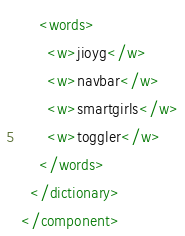<code> <loc_0><loc_0><loc_500><loc_500><_XML_>    <words>
      <w>jioyg</w>
      <w>navbar</w>
      <w>smartgirls</w>
      <w>toggler</w>
    </words>
  </dictionary>
</component></code> 